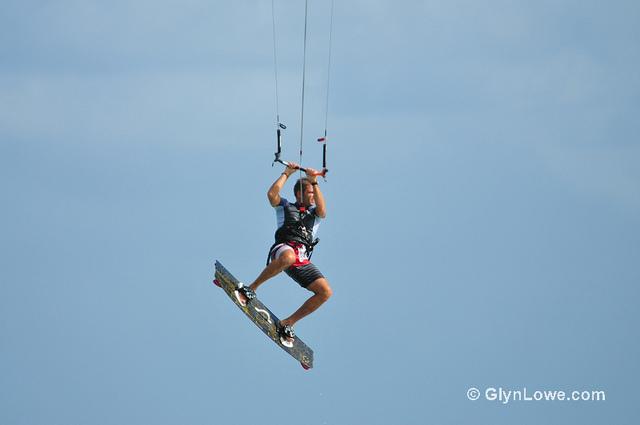Is the sky blue?
Concise answer only. Yes. What is attached to the man's feet?
Be succinct. Wakeboard. What is the website listed on the picture?
Quick response, please. Glynlowe.com. What is the guy on?
Give a very brief answer. Wakeboard. 